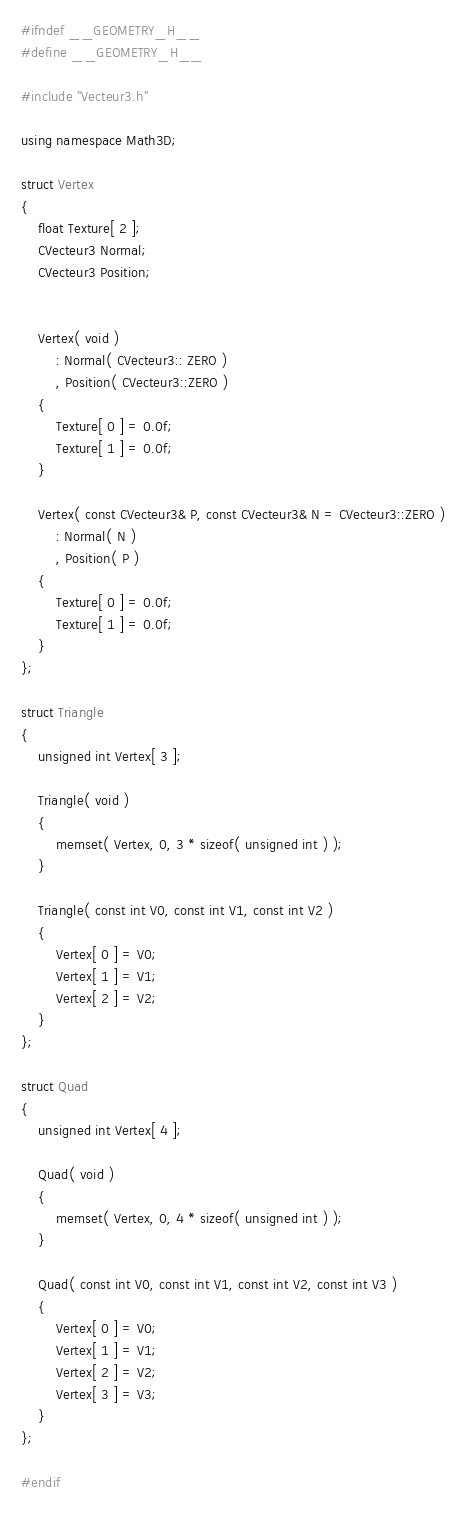Convert code to text. <code><loc_0><loc_0><loc_500><loc_500><_C_>#ifndef __GEOMETRY_H__
#define __GEOMETRY_H__

#include "Vecteur3.h"

using namespace Math3D;

struct Vertex
{
    float Texture[ 2 ];
    CVecteur3 Normal;
    CVecteur3 Position;
    

    Vertex( void )
        : Normal( CVecteur3:: ZERO )
        , Position( CVecteur3::ZERO )
    {
        Texture[ 0 ] = 0.0f;
        Texture[ 1 ] = 0.0f;
    }

    Vertex( const CVecteur3& P, const CVecteur3& N = CVecteur3::ZERO )
        : Normal( N )
        , Position( P )
    {
        Texture[ 0 ] = 0.0f;
        Texture[ 1 ] = 0.0f;
    }
};

struct Triangle
{
    unsigned int Vertex[ 3 ];

    Triangle( void )
    {
        memset( Vertex, 0, 3 * sizeof( unsigned int ) );
    }

    Triangle( const int V0, const int V1, const int V2 )
    {
        Vertex[ 0 ] = V0;
        Vertex[ 1 ] = V1;
        Vertex[ 2 ] = V2;
    }
};

struct Quad
{
    unsigned int Vertex[ 4 ];

    Quad( void )
    {
        memset( Vertex, 0, 4 * sizeof( unsigned int ) );
    }

    Quad( const int V0, const int V1, const int V2, const int V3 )
    {
        Vertex[ 0 ] = V0;
        Vertex[ 1 ] = V1;
        Vertex[ 2 ] = V2;
        Vertex[ 3 ] = V3;
    }
};

#endif</code> 